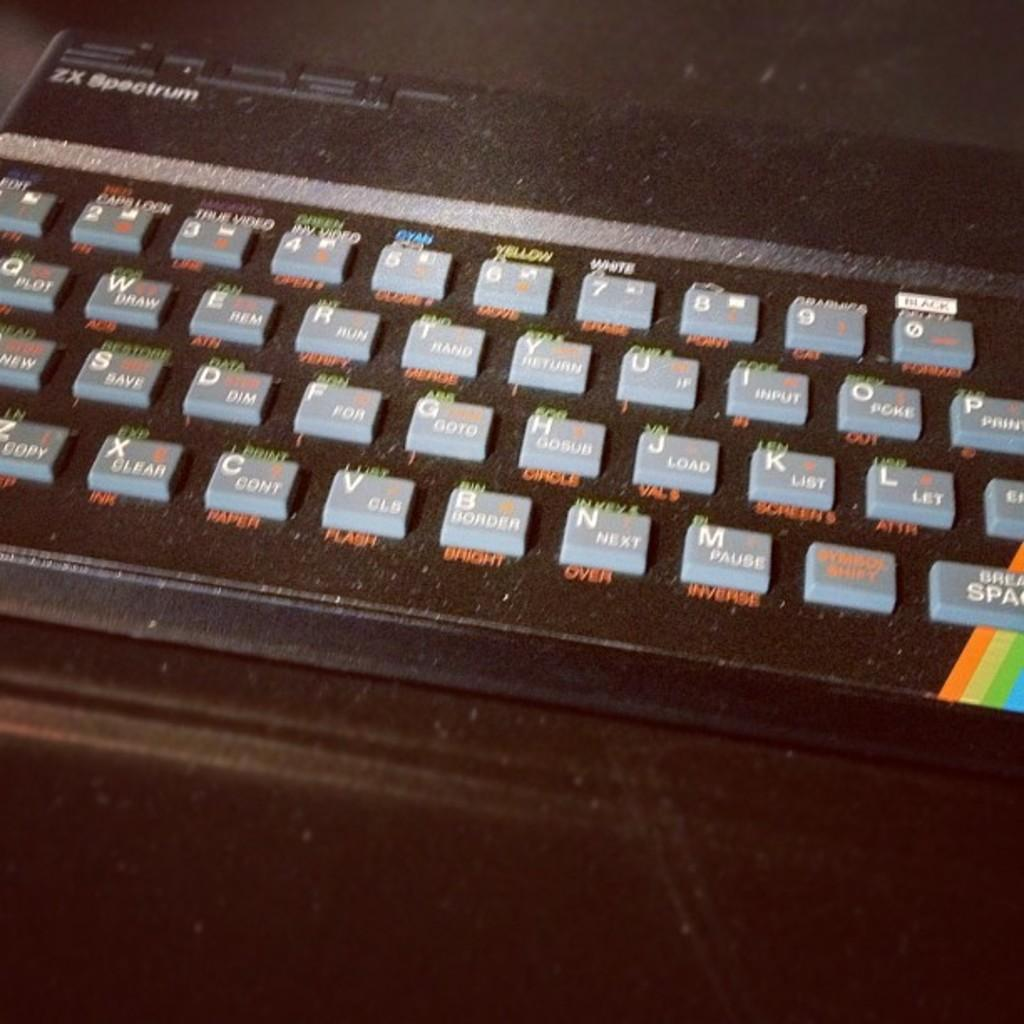<image>
Describe the image concisely. An old black ZX Spectrum qwerty keyboard with a rainbow design in its bottom right corner. 